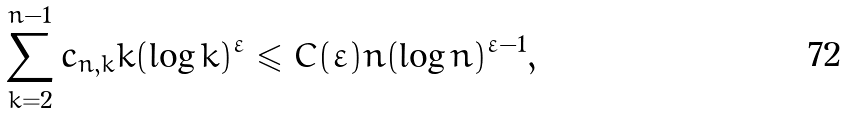<formula> <loc_0><loc_0><loc_500><loc_500>\sum _ { k = 2 } ^ { n - 1 } c _ { n , k } k ( \log k ) ^ { \varepsilon } \leqslant C ( \varepsilon ) n ( \log n ) ^ { \varepsilon - 1 } ,</formula> 